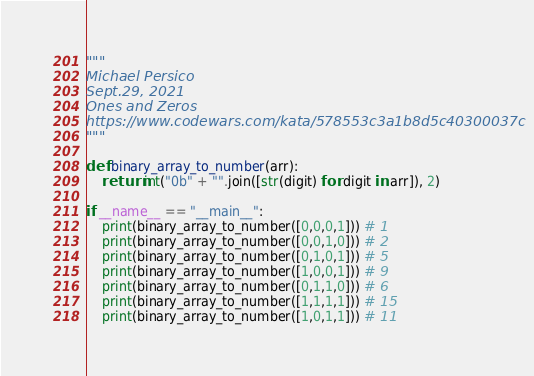Convert code to text. <code><loc_0><loc_0><loc_500><loc_500><_Python_>"""
Michael Persico
Sept.29, 2021
Ones and Zeros
https://www.codewars.com/kata/578553c3a1b8d5c40300037c
"""

def binary_array_to_number(arr):
    return int("0b" + "".join([str(digit) for digit in arr]), 2)

if __name__ == "__main__":
    print(binary_array_to_number([0,0,0,1])) # 1
    print(binary_array_to_number([0,0,1,0])) # 2
    print(binary_array_to_number([0,1,0,1])) # 5
    print(binary_array_to_number([1,0,0,1])) # 9
    print(binary_array_to_number([0,1,1,0])) # 6
    print(binary_array_to_number([1,1,1,1])) # 15
    print(binary_array_to_number([1,0,1,1])) # 11
</code> 